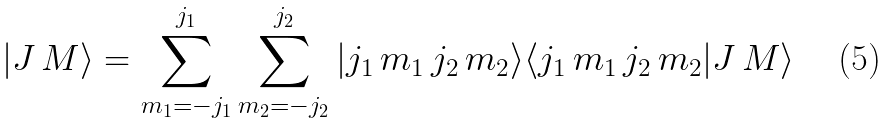Convert formula to latex. <formula><loc_0><loc_0><loc_500><loc_500>| J \, M \rangle = \sum _ { m _ { 1 } = - j _ { 1 } } ^ { j _ { 1 } } \sum _ { m _ { 2 } = - j _ { 2 } } ^ { j _ { 2 } } | j _ { 1 } \, m _ { 1 } \, j _ { 2 } \, m _ { 2 } \rangle \langle j _ { 1 } \, m _ { 1 } \, j _ { 2 } \, m _ { 2 } | J \, M \rangle</formula> 